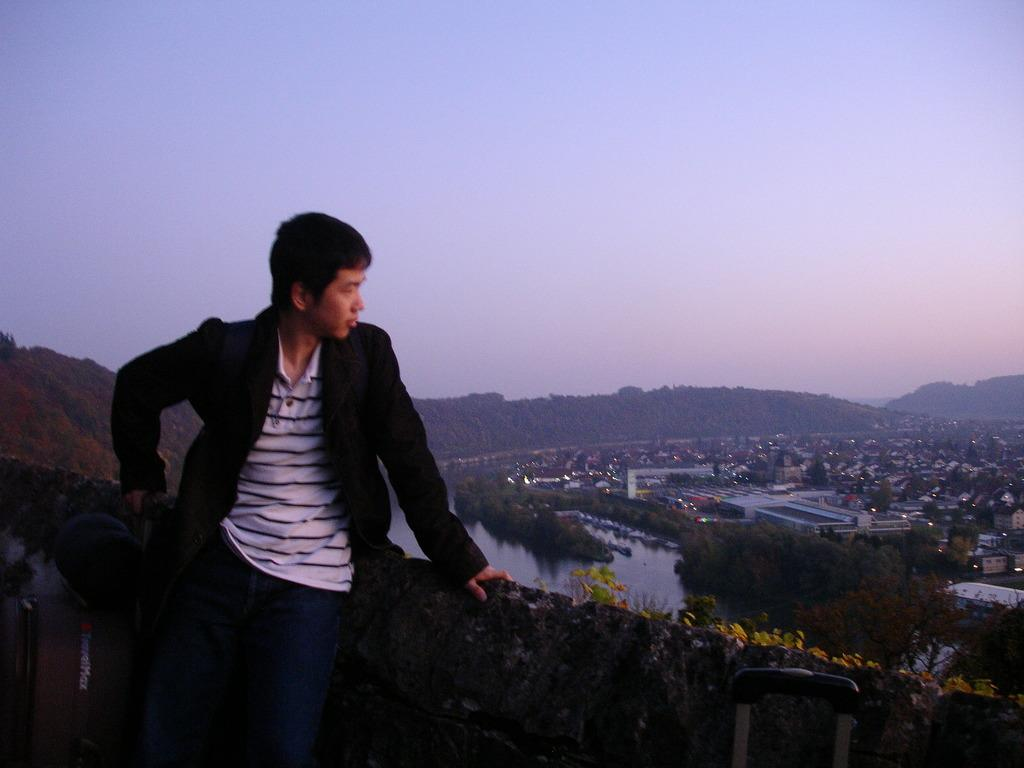What is the main subject in the image? There is a person standing in the image. Where is the person standing? The person is standing in front of a wall. What is located beside the person? There is a luggage beside the person. What can be seen behind the wall? There is a lake, houses, and trees behind the wall. What degree does the person in the image have? There is no information about the person's degree in the image. Is the person holding a gun in the image? There is no gun present in the image. 